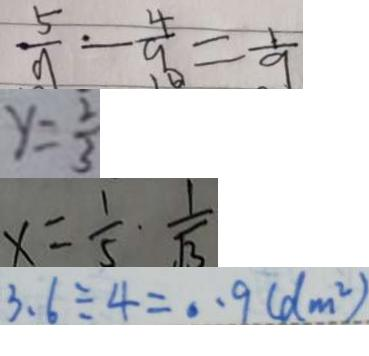Convert formula to latex. <formula><loc_0><loc_0><loc_500><loc_500>\frac { 5 } { 9 } - \frac { 4 } { 9 } = \frac { 1 } { 9 } 
 y = \frac { 2 } { 3 } 
 x = \frac { 1 } { 5 } \cdot \frac { 1 } { \sqrt { 3 } } 
 3 . 6 \div 4 = 0 . 9 ( d m ^ { 2 } )</formula> 